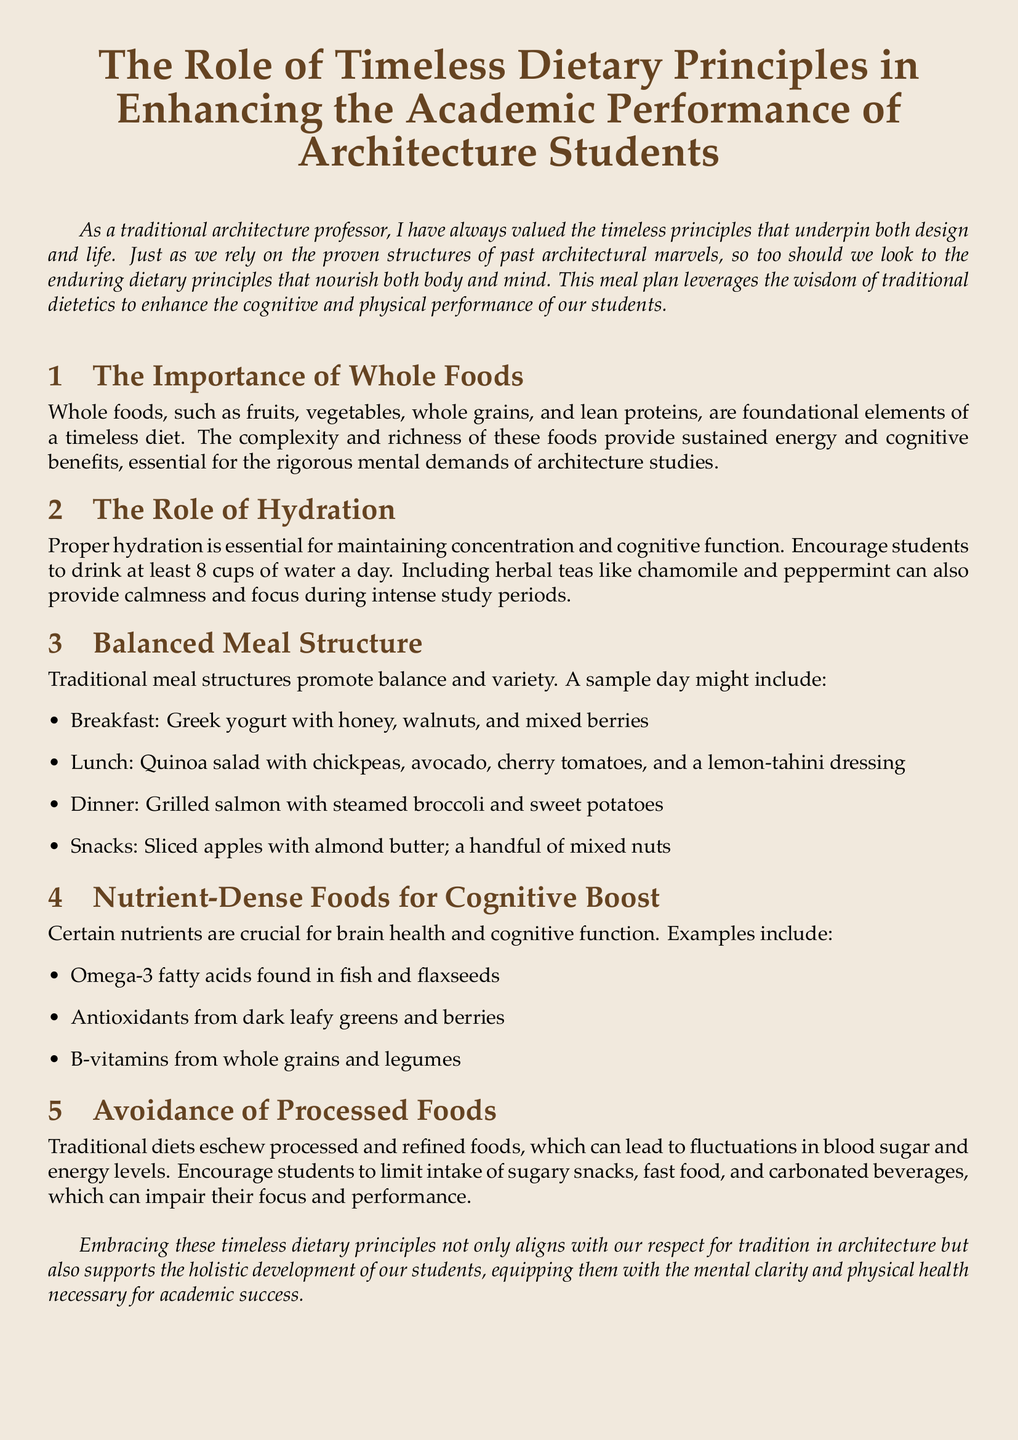What is the primary focus of the meal plan? The meal plan focuses on enhancing the academic performance of architecture students through timeless dietary principles.
Answer: Enhancing academic performance What does the meal plan suggest for breakfast? The meal plan suggests Greek yogurt with honey, walnuts, and mixed berries for breakfast.
Answer: Greek yogurt with honey, walnuts, and mixed berries How many cups of water should students drink daily? The document recommends students drink at least 8 cups of water a day for proper hydration.
Answer: 8 cups What type of oils are highlighted for cognitive benefits? Omega-3 fatty acids found in fish and flaxseeds are highlighted as beneficial for cognitive function.
Answer: Omega-3 fatty acids Which food is suggested as a snack option? The document lists sliced apples with almond butter as one of the snack options.
Answer: Sliced apples with almond butter What is the role of whole foods in the meal plan? Whole foods are described as foundational elements that provide sustained energy and cognitive benefits.
Answer: Foundational elements What is advised against in the dietary recommendations? The document advises against the intake of processed and refined foods.
Answer: Processed and refined foods Which day meal structure is provided in the plan? The meal plan provides a balanced meal structure including breakfast, lunch, dinner, and snacks.
Answer: Balanced meal structure 